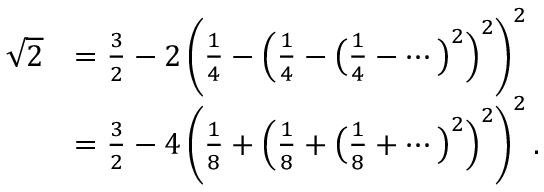Convert formula to latex. <formula><loc_0><loc_0><loc_500><loc_500>{ \begin{array} { r l } { { \sqrt { 2 } } } & { = { \frac { 3 } { 2 } } - 2 \left ( { \frac { 1 } { 4 } } - \left ( { \frac { 1 } { 4 } } - { \left ( } { \frac { 1 } { 4 } } - \cdots { \right ) } ^ { 2 } \right ) ^ { 2 } \right ) ^ { 2 } } \\ & { = { \frac { 3 } { 2 } } - 4 \left ( { \frac { 1 } { 8 } } + \left ( { \frac { 1 } { 8 } } + { \left ( } { \frac { 1 } { 8 } } + \cdots { \right ) } ^ { 2 } \right ) ^ { 2 } \right ) ^ { 2 } . } \end{array} }</formula> 